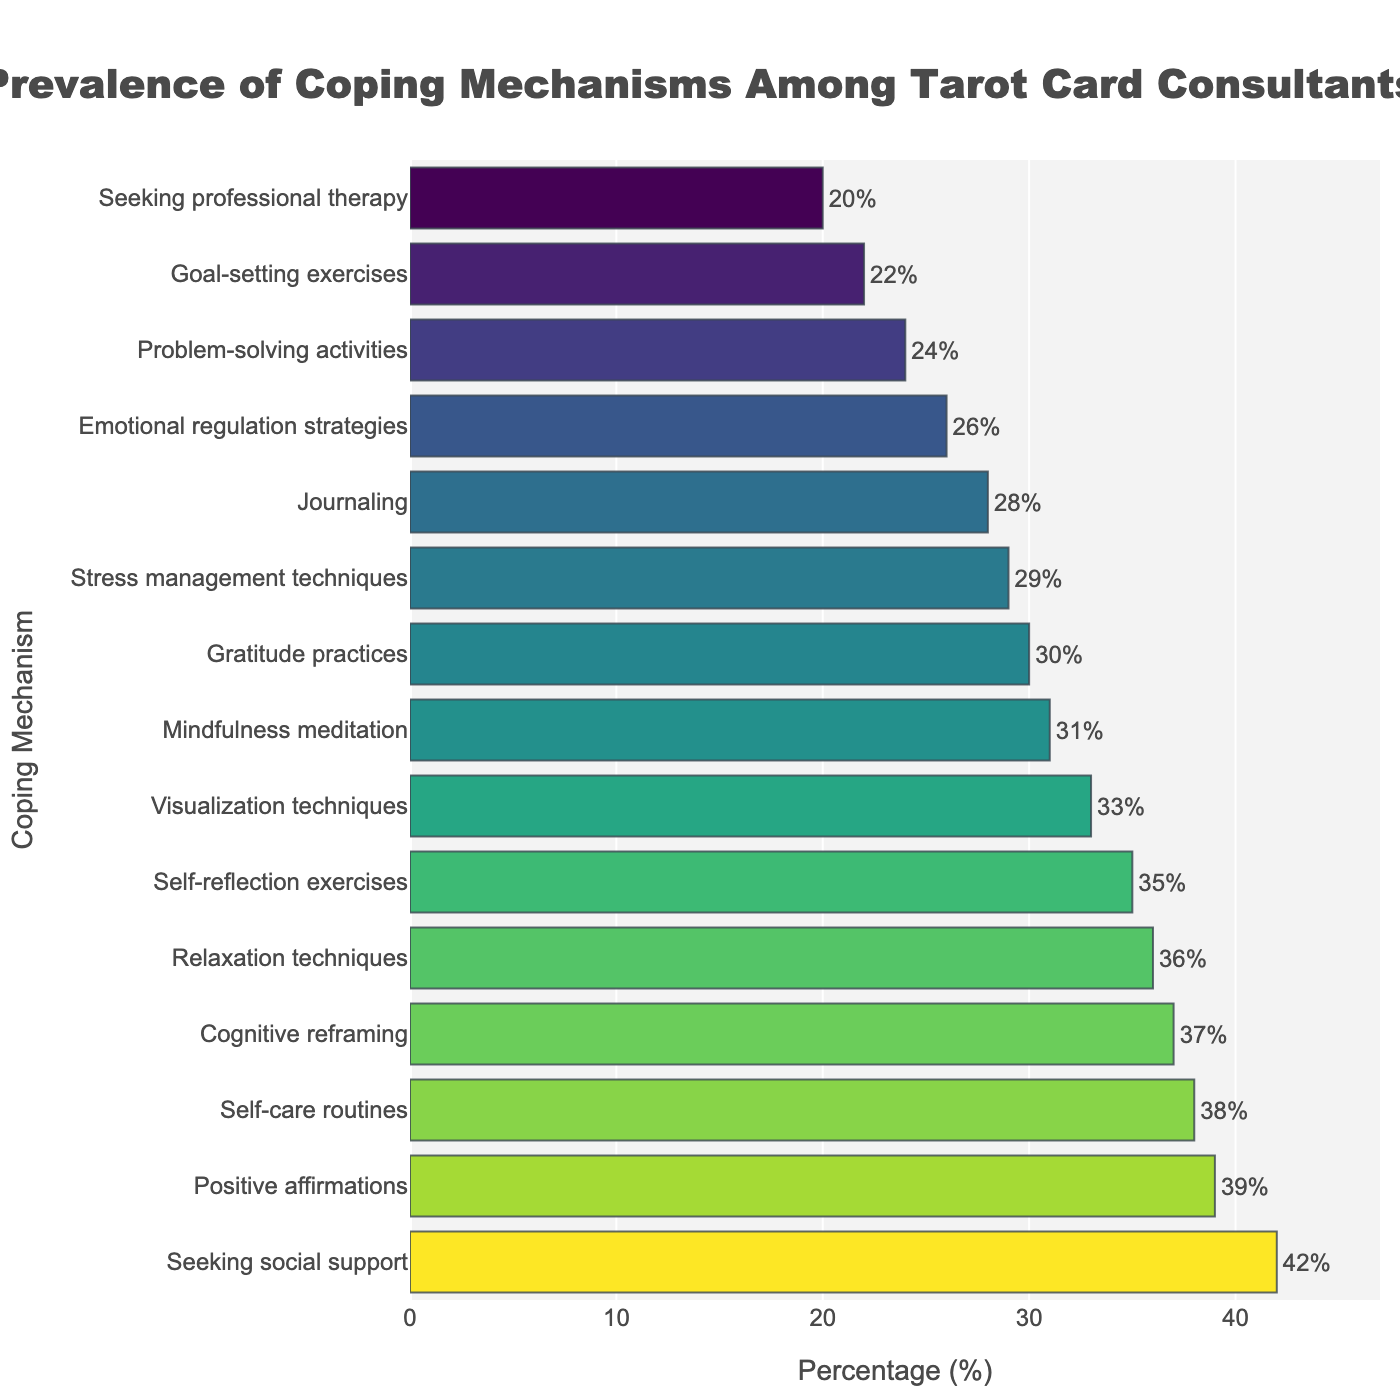Which coping mechanism is reported by the highest percentage of tarot card consultants? By examining the figure, the coping mechanism with the tallest bar represents the highest percentage. The tallest bar corresponds to "Seeking social support," which is reported by 42%.
Answer: Seeking social support What is the combined percentage of individuals practicing Cognitive reframing and Mindfulness meditation? Add the percentages of individuals practicing Cognitive reframing (37%) and Mindfulness meditation (31%): 37 + 31 = 68
Answer: 68 How much higher is the percentage of "Positive affirmations" compared to "Problem-solving activities"? Subtract the percentage of "Problem-solving activities" (24%) from the percentage of "Positive affirmations" (39%): 39 - 24 = 15
Answer: 15 Which coping mechanisms are practiced by more than 35 percent of respondents? Identify bars with a length greater than 35%. The bars representing "Seeking social support" (42%), "Positive affirmations" (39%), "Self-care routines" (38%), "Cognitive reframing" (37%), and "Relaxation techniques" (36%) all meet this criteria.
Answer: Seeking social support, Positive affirmations, Self-care routines, Cognitive reframing, Relaxation techniques What is the average percentage of individuals practicing Gratitude practices, Self-care routines, and Emotional regulation strategies? Sum the percentages of these mechanisms and divide by the number of mechanisms: (30 + 38 + 26) / 3 = 94 / 3 ≈ 31.33
Answer: 31.33 Are there more individuals practicing Journaling or Stress management techniques? Compare the lengths of the bars for Journaling (28%) and Stress management techniques (29%). The bar for Stress management techniques is slightly longer.
Answer: Stress management techniques What is the visual characteristic that distinguishes the coping mechanism with the lowest percentage from others? The shortest bar in the figure represents the coping mechanism with the lowest percentage. This bar is associated with "Seeking professional therapy" at 20%.
Answer: Shortest bar What is the difference between the highest and the lowest reported coping mechanism percentages? Subtract the percentage of the lowest mechanism (Seeking professional therapy at 20%) from the highest (Seeking social support at 42%): 42 - 20 = 22
Answer: 22 Are Relaxation techniques used more frequently than Visualization techniques? Compare the lengths of the bars for Relaxation techniques (36%) and Visualization techniques (33%). The relaxation techniques bar is longer.
Answer: Yes 